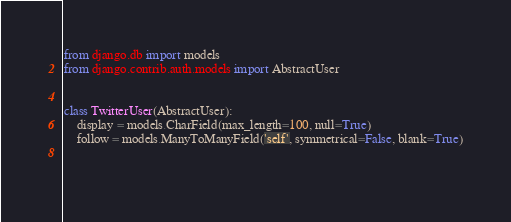Convert code to text. <code><loc_0><loc_0><loc_500><loc_500><_Python_>from django.db import models
from django.contrib.auth.models import AbstractUser


class TwitterUser(AbstractUser):
    display = models.CharField(max_length=100, null=True)
    follow = models.ManyToManyField('self', symmetrical=False, blank=True)

    
</code> 